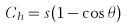Convert formula to latex. <formula><loc_0><loc_0><loc_500><loc_500>C _ { h } = s ( 1 - \cos \theta )</formula> 